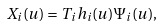Convert formula to latex. <formula><loc_0><loc_0><loc_500><loc_500>X _ { i } ( u ) = T _ { i } h _ { i } ( u ) \Psi _ { i } ( u ) ,</formula> 